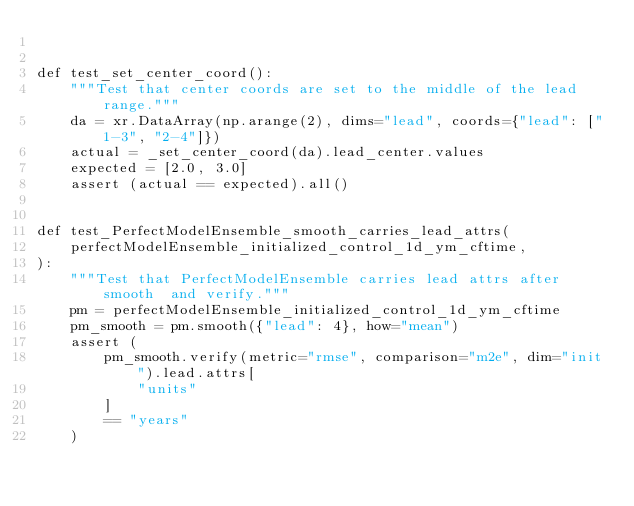<code> <loc_0><loc_0><loc_500><loc_500><_Python_>

def test_set_center_coord():
    """Test that center coords are set to the middle of the lead range."""
    da = xr.DataArray(np.arange(2), dims="lead", coords={"lead": ["1-3", "2-4"]})
    actual = _set_center_coord(da).lead_center.values
    expected = [2.0, 3.0]
    assert (actual == expected).all()


def test_PerfectModelEnsemble_smooth_carries_lead_attrs(
    perfectModelEnsemble_initialized_control_1d_ym_cftime,
):
    """Test that PerfectModelEnsemble carries lead attrs after smooth  and verify."""
    pm = perfectModelEnsemble_initialized_control_1d_ym_cftime
    pm_smooth = pm.smooth({"lead": 4}, how="mean")
    assert (
        pm_smooth.verify(metric="rmse", comparison="m2e", dim="init").lead.attrs[
            "units"
        ]
        == "years"
    )
</code> 